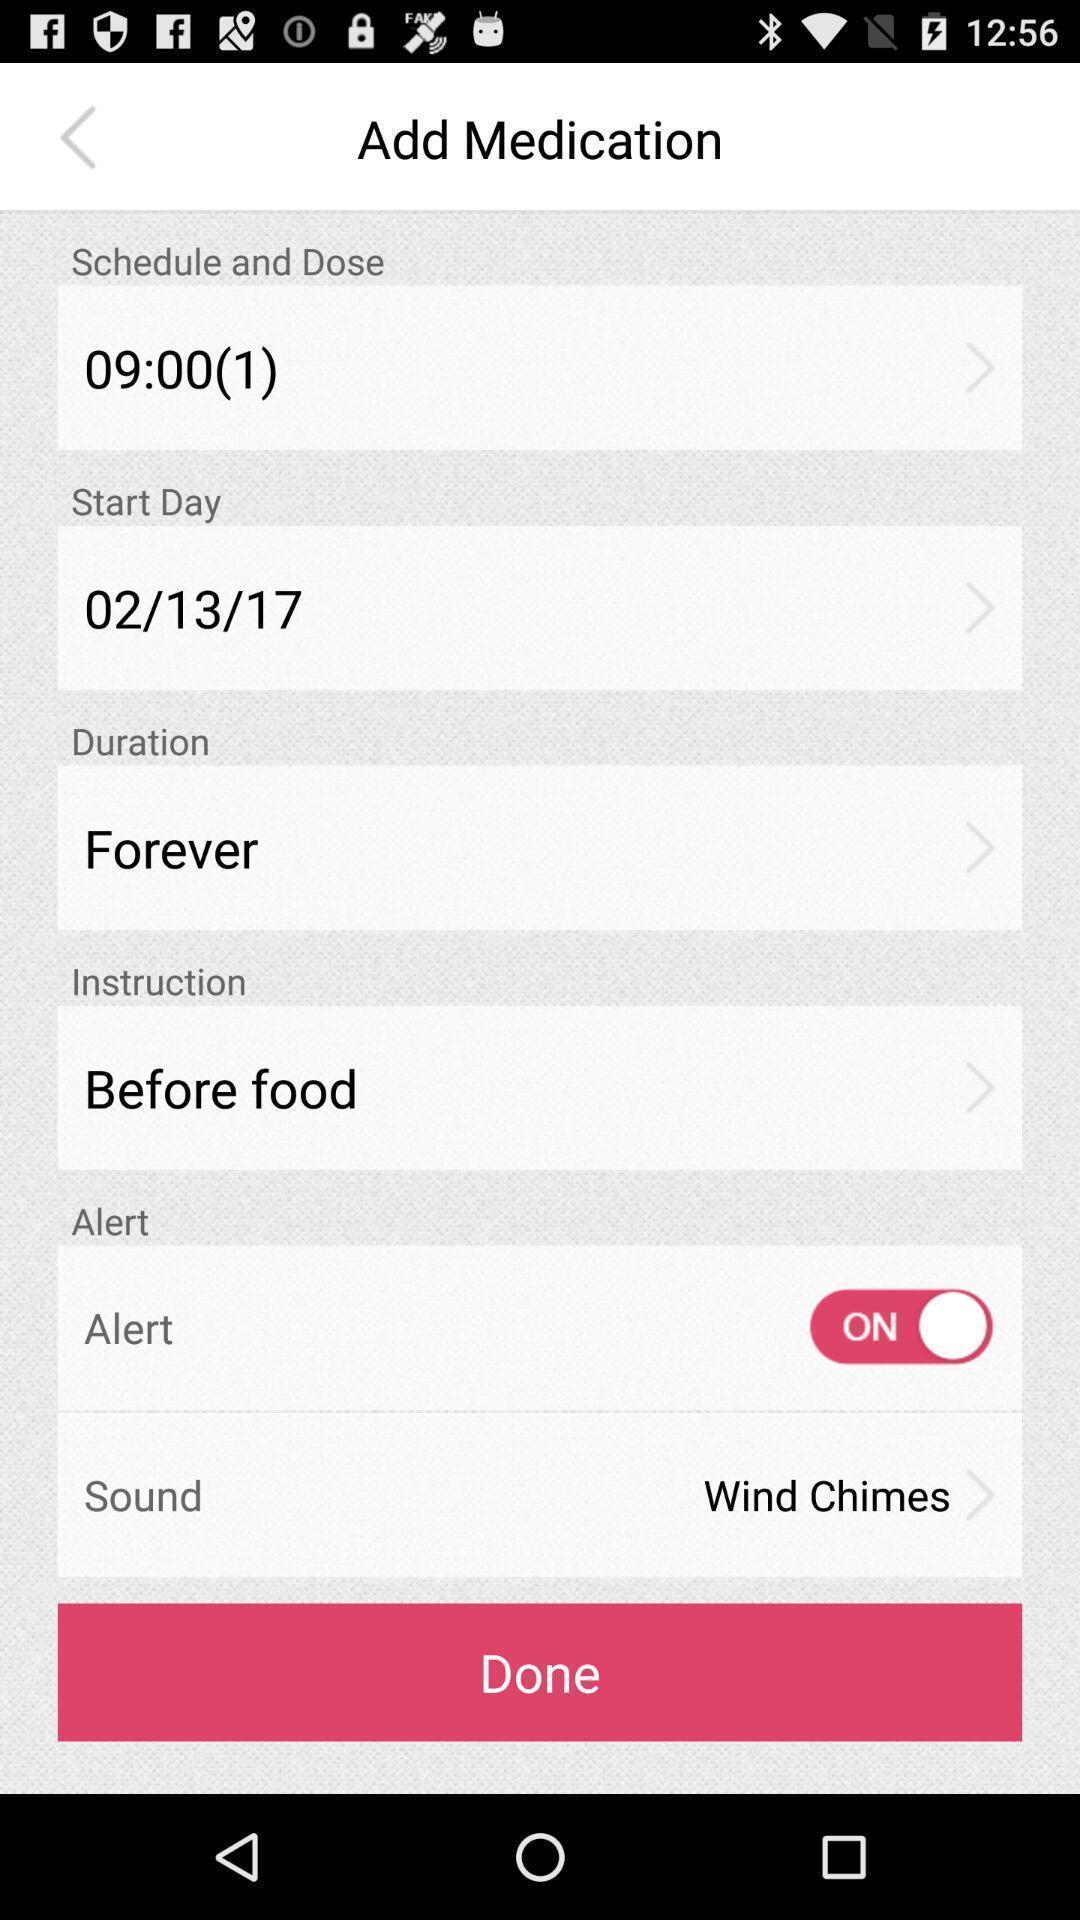What is the overall content of this screenshot? Page of a medication reminder app. 